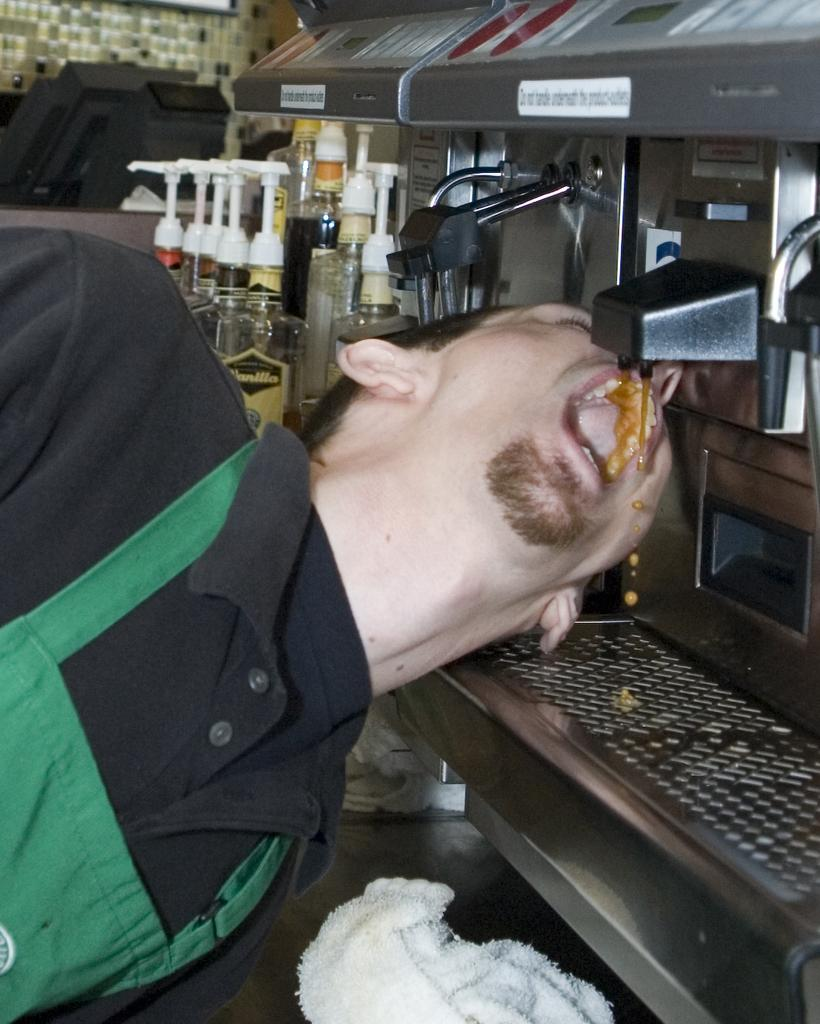What is the person in the image doing? The person is standing and drinking something in the image. What can be seen in the image besides the person? There is a machine and objects on a table in the image. What direction is the pig facing in the image? There is no pig present in the image. 